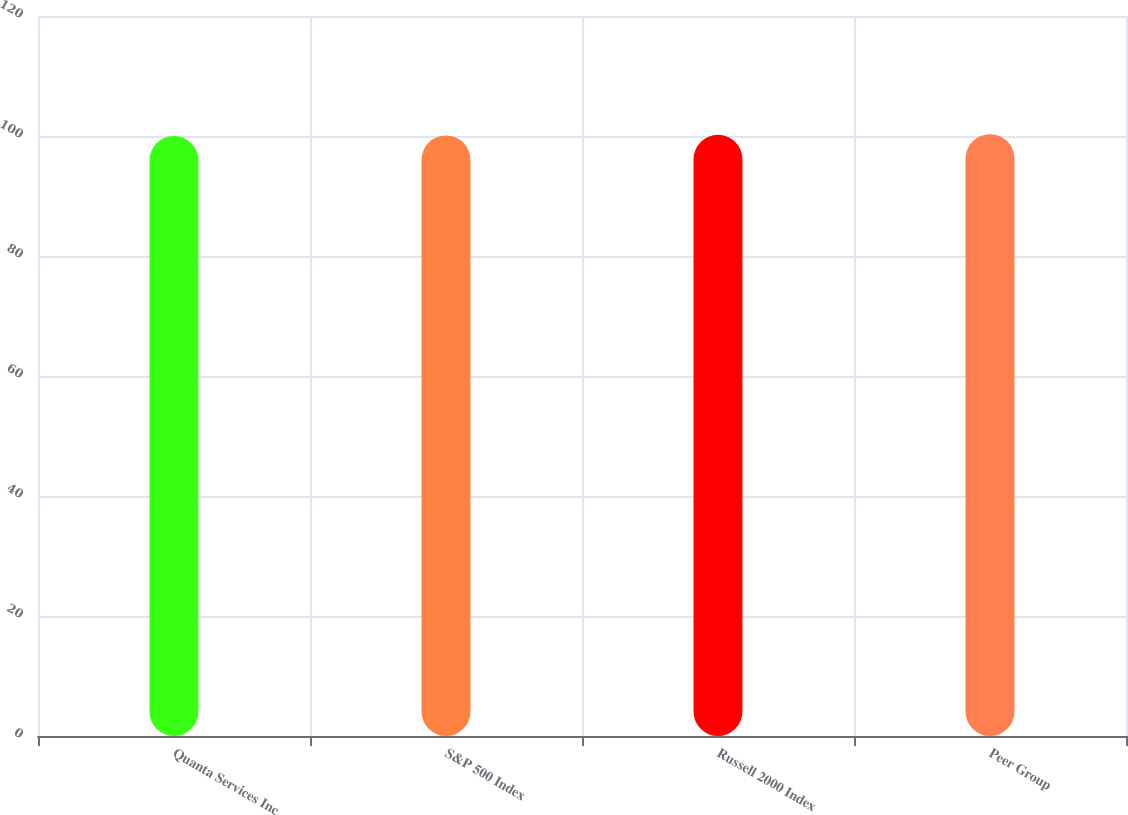<chart> <loc_0><loc_0><loc_500><loc_500><bar_chart><fcel>Quanta Services Inc<fcel>S&P 500 Index<fcel>Russell 2000 Index<fcel>Peer Group<nl><fcel>100<fcel>100.1<fcel>100.2<fcel>100.3<nl></chart> 